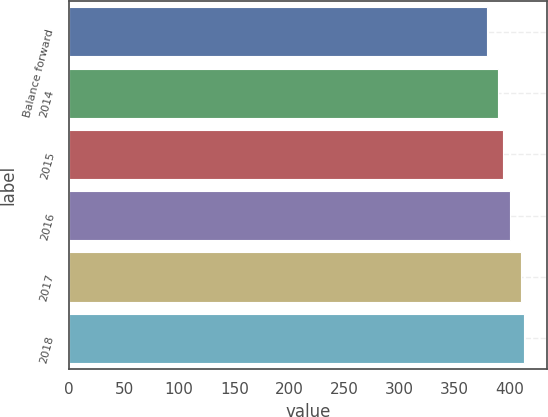Convert chart to OTSL. <chart><loc_0><loc_0><loc_500><loc_500><bar_chart><fcel>Balance forward<fcel>2014<fcel>2015<fcel>2016<fcel>2017<fcel>2018<nl><fcel>379<fcel>389<fcel>394<fcel>400<fcel>410<fcel>413.1<nl></chart> 